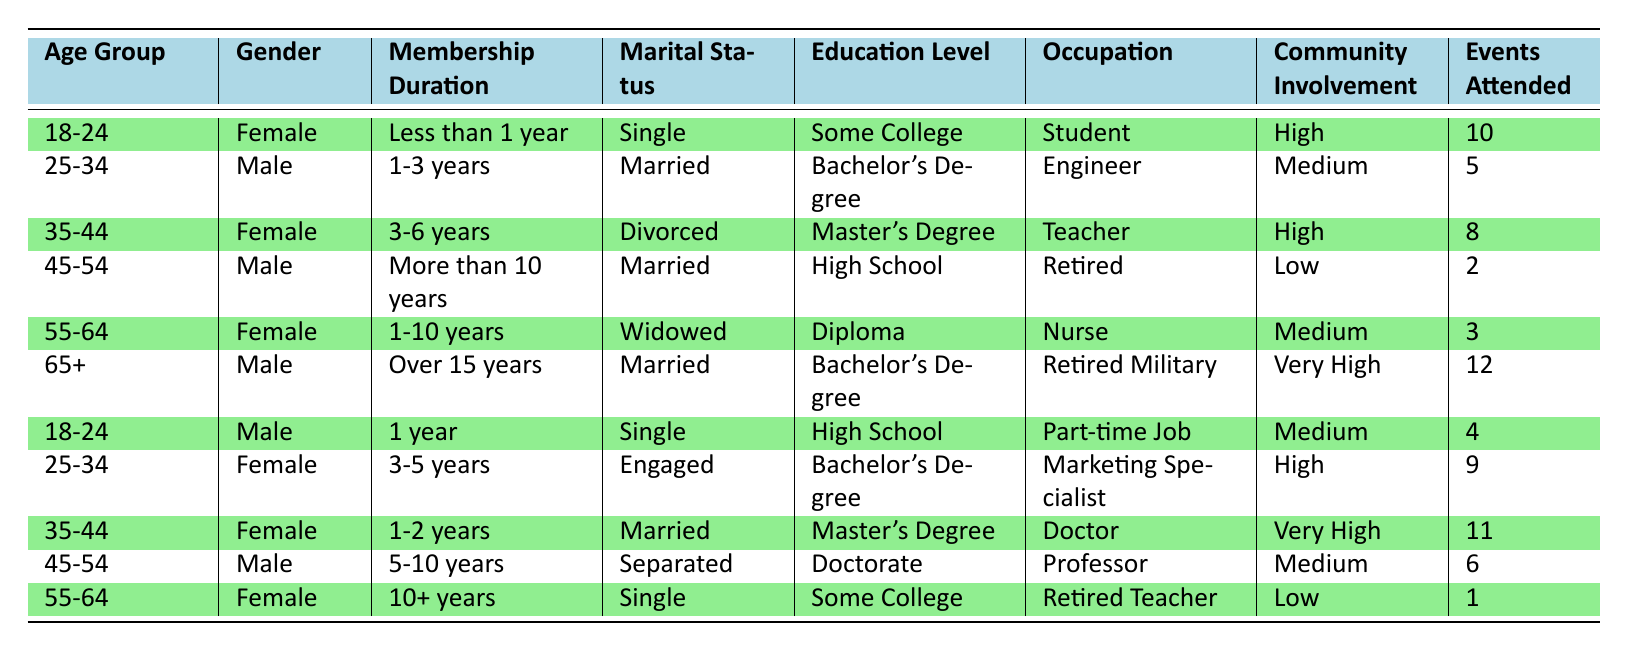What is the most common age group among the congregation members? The table has members from various age groups: 18-24, 25-34, 35-44, 45-54, 55-64, and 65+. By counting the occurrences, we find there are two entries for the 18-24 age group and two for the 25-34 age group, while all other groups have one entry each. Thus, there is a tie between 18-24 and 25-34 as the most common age groups.
Answer: 18-24 and 25-34 What is the gender of the oldest congregation member? Checking the age groups, the only member aged 65 and above is male, who is listed in the 65+ age group. Therefore, the oldest member of the congregation is male.
Answer: Male How many members have been part of the congregation for more than 10 years? There are two duration categories that exceed 10 years: "More than 10 years" and "Over 15 years." The table indicates one male member in the first category and one male member in the second category. Thus, there are two members who have been part of the congregation for more than 10 years.
Answer: 2 What percentage of members have high community involvement? The table indicates community involvement levels: High, Medium, Low, and Very High. Specifically, there are three members identified as having High involvement and two as Very High involvement. With a total of 11 members, calculating the percentage involves adding the members from the High and Very High levels: (3 + 2) / 11 * 100 = 45.45%, which rounds down to 45%.
Answer: 45% Is there a member who has attended more than 10 events? By examining the "Events Attended" column, we see that there are two entries: one member attended 11 events, and another attended 12. Thus, there are indeed members who have attended more than 10 events.
Answer: Yes What age group has the highest average attendance at events, and what is that average? We need to first categorize members by age groups and their respective event attendance. The age groups and their total attendance are as follows: 18-24 (10 + 4 = 14, average 7), 25-34 (5 + 9 = 14, average 7), 35-44 (8 + 11 = 19, average 9.5), 45-54 (2 + 6 = 8, average 4), 55-64 (3 + 1 = 4, average 2), 65+ (12). The highest average of 12 events attended belongs to the 65+ age group.
Answer: 65+ age group, average 12 Which marital status is most prevalent in the congregation? By analyzing the "Marital Status" column, we find the following counts: Single (3), Married (4), Engaged (1), Divorced (1), and Separated (1). The status with the highest count is Married with a total of four members.
Answer: Married Are there any members with only a High School education? The table indicates two members with a High School education: one in the 18-24 age group and another in the 45-54 age group. Since there are members with a High School education, the answer is yes.
Answer: Yes What is the average membership duration of all members? The membership durations are categorized as follows: Less than 1 year (1), 1 year (1), 1-3 years (2), 3-5 years (4), 5-10 years (6), More than 10 years (10), and Over 15 years (15). This gives us an average duration of (0.5 + 1 + 2 + 4 + 7.5 + 10 + 15) / 11 = 5.41 years.
Answer: 5.41 years 